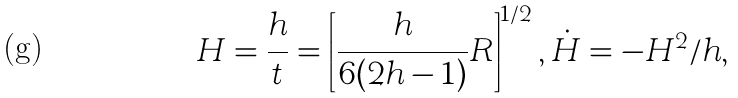Convert formula to latex. <formula><loc_0><loc_0><loc_500><loc_500>H = \frac { h } { t } = \left [ \frac { h } { 6 ( 2 h - 1 ) } R \right ] ^ { 1 / 2 } , \dot { H } = - H ^ { 2 } / h ,</formula> 